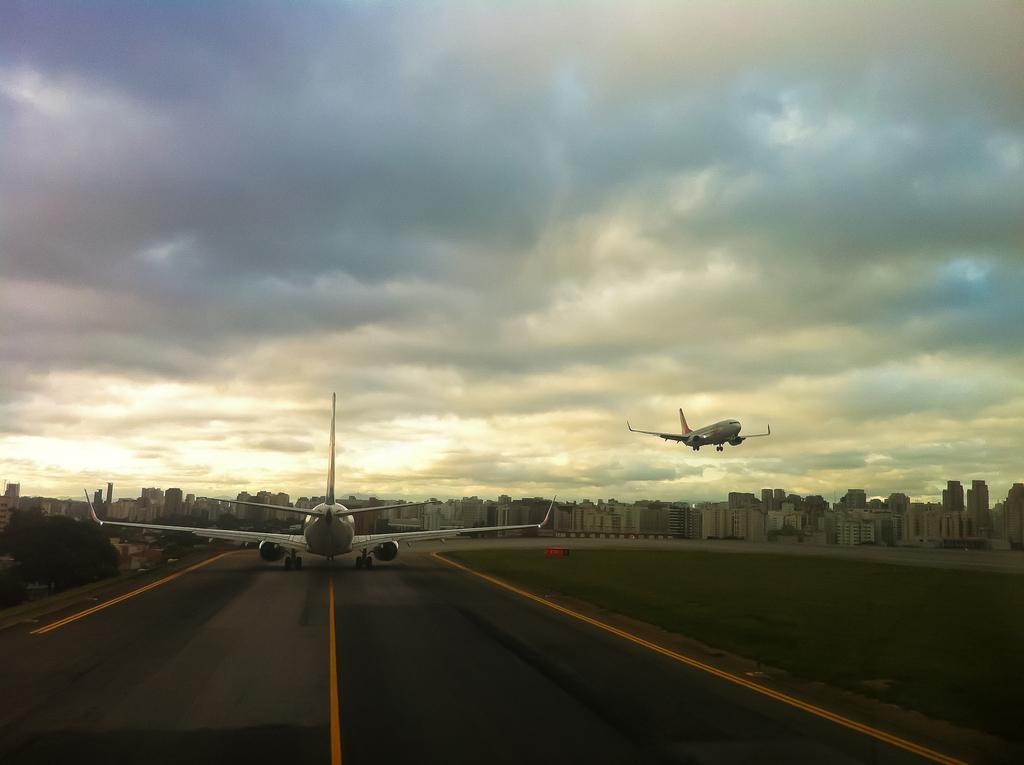Could you give a brief overview of what you see in this image? This picture might be taken on the wide road. In this image, on the left side, we can see an airplane moving on the road. On the right side, we can also see an airplane flying in the air. In the background, we can see some plants, trees, buildings. At the top, we can see a sky which is cloudy, at the bottom there is a road. 